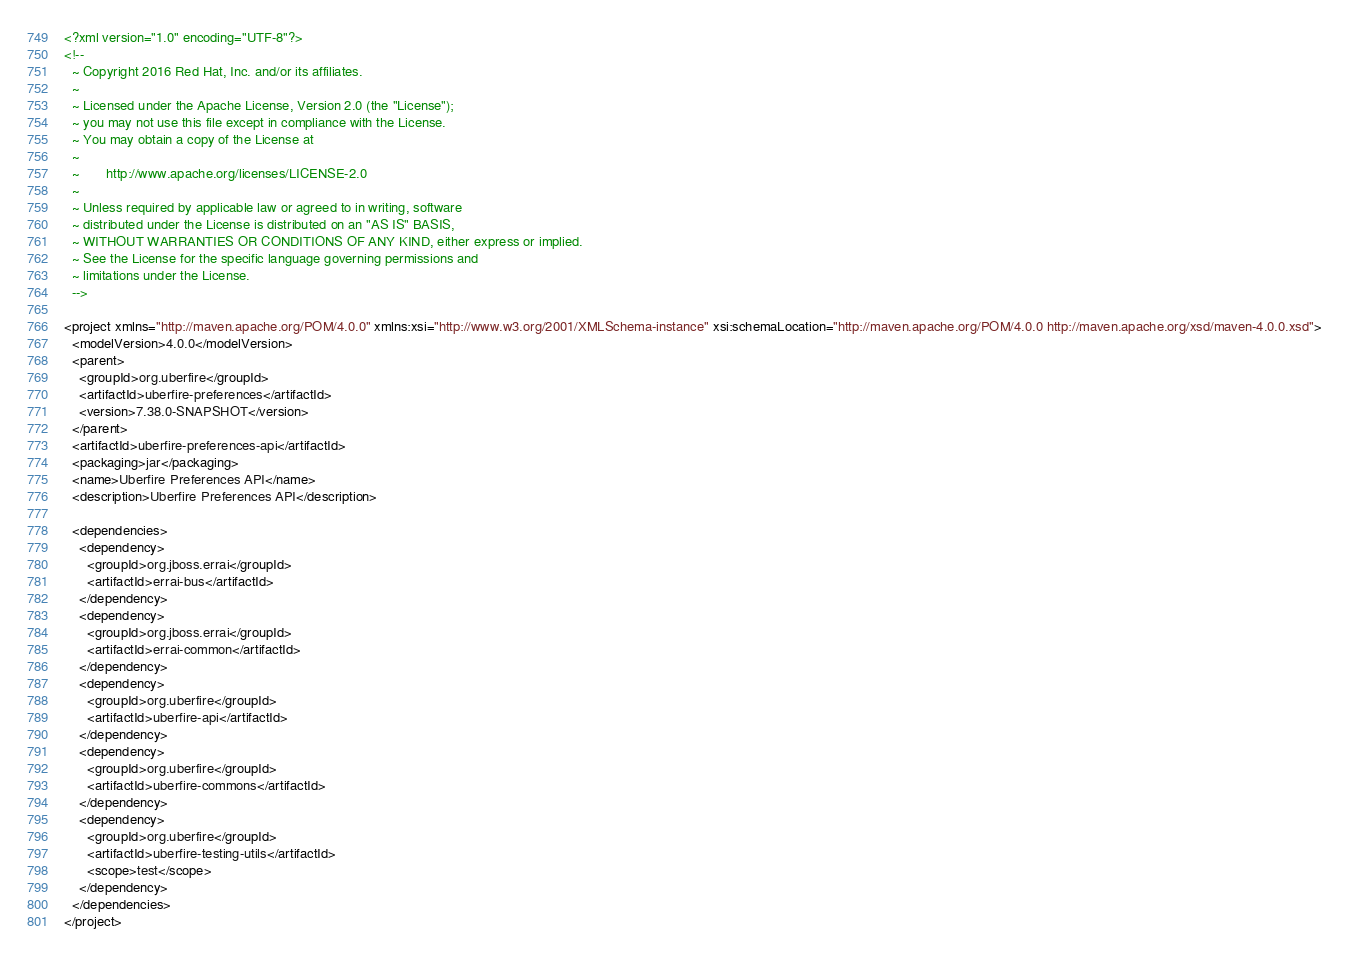<code> <loc_0><loc_0><loc_500><loc_500><_XML_><?xml version="1.0" encoding="UTF-8"?>
<!--
  ~ Copyright 2016 Red Hat, Inc. and/or its affiliates.
  ~
  ~ Licensed under the Apache License, Version 2.0 (the "License");
  ~ you may not use this file except in compliance with the License.
  ~ You may obtain a copy of the License at
  ~
  ~       http://www.apache.org/licenses/LICENSE-2.0
  ~
  ~ Unless required by applicable law or agreed to in writing, software
  ~ distributed under the License is distributed on an "AS IS" BASIS,
  ~ WITHOUT WARRANTIES OR CONDITIONS OF ANY KIND, either express or implied.
  ~ See the License for the specific language governing permissions and
  ~ limitations under the License.
  -->

<project xmlns="http://maven.apache.org/POM/4.0.0" xmlns:xsi="http://www.w3.org/2001/XMLSchema-instance" xsi:schemaLocation="http://maven.apache.org/POM/4.0.0 http://maven.apache.org/xsd/maven-4.0.0.xsd">
  <modelVersion>4.0.0</modelVersion>
  <parent>
    <groupId>org.uberfire</groupId>
    <artifactId>uberfire-preferences</artifactId>
    <version>7.38.0-SNAPSHOT</version>
  </parent>
  <artifactId>uberfire-preferences-api</artifactId>
  <packaging>jar</packaging>
  <name>Uberfire Preferences API</name>
  <description>Uberfire Preferences API</description>

  <dependencies>
    <dependency>
      <groupId>org.jboss.errai</groupId>
      <artifactId>errai-bus</artifactId>
    </dependency>
    <dependency>
      <groupId>org.jboss.errai</groupId>
      <artifactId>errai-common</artifactId>
    </dependency>
    <dependency>
      <groupId>org.uberfire</groupId>
      <artifactId>uberfire-api</artifactId>
    </dependency>
    <dependency>
      <groupId>org.uberfire</groupId>
      <artifactId>uberfire-commons</artifactId>
    </dependency>
    <dependency>
      <groupId>org.uberfire</groupId>
      <artifactId>uberfire-testing-utils</artifactId>
      <scope>test</scope>
    </dependency>
  </dependencies>
</project></code> 